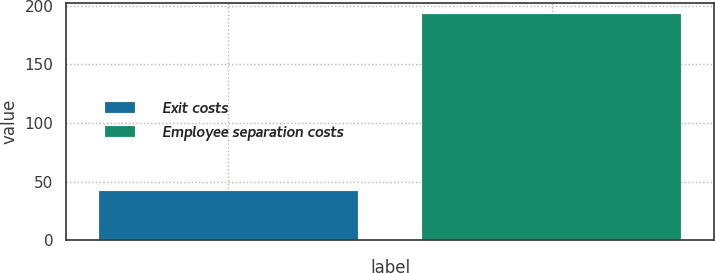Convert chart. <chart><loc_0><loc_0><loc_500><loc_500><bar_chart><fcel>Exit costs<fcel>Employee separation costs<nl><fcel>42<fcel>193<nl></chart> 